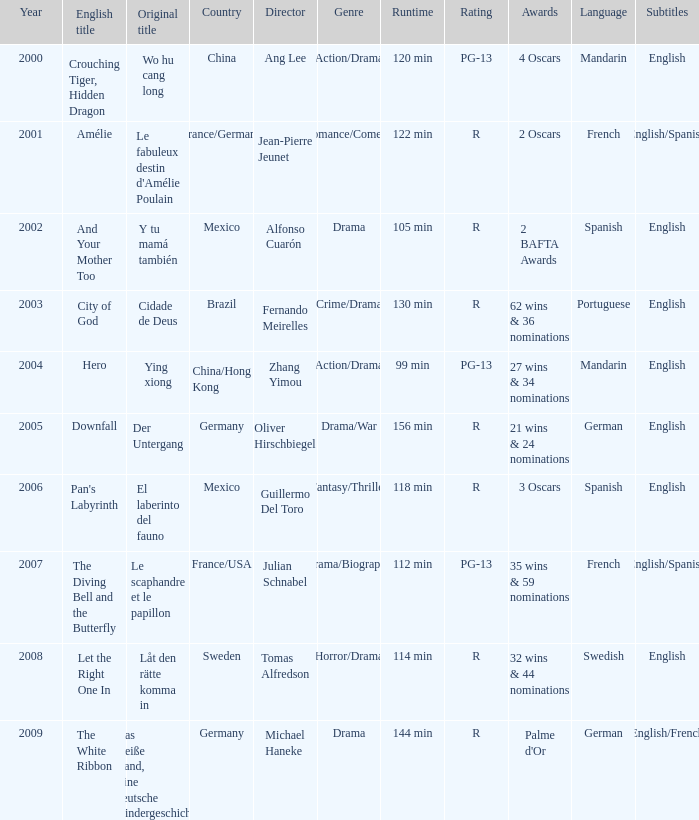Name the title of jean-pierre jeunet Amélie. 